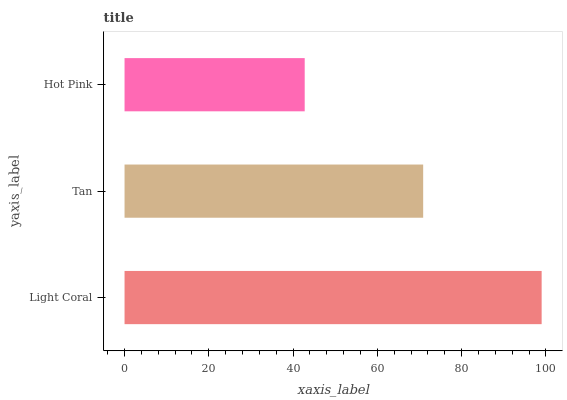Is Hot Pink the minimum?
Answer yes or no. Yes. Is Light Coral the maximum?
Answer yes or no. Yes. Is Tan the minimum?
Answer yes or no. No. Is Tan the maximum?
Answer yes or no. No. Is Light Coral greater than Tan?
Answer yes or no. Yes. Is Tan less than Light Coral?
Answer yes or no. Yes. Is Tan greater than Light Coral?
Answer yes or no. No. Is Light Coral less than Tan?
Answer yes or no. No. Is Tan the high median?
Answer yes or no. Yes. Is Tan the low median?
Answer yes or no. Yes. Is Hot Pink the high median?
Answer yes or no. No. Is Light Coral the low median?
Answer yes or no. No. 